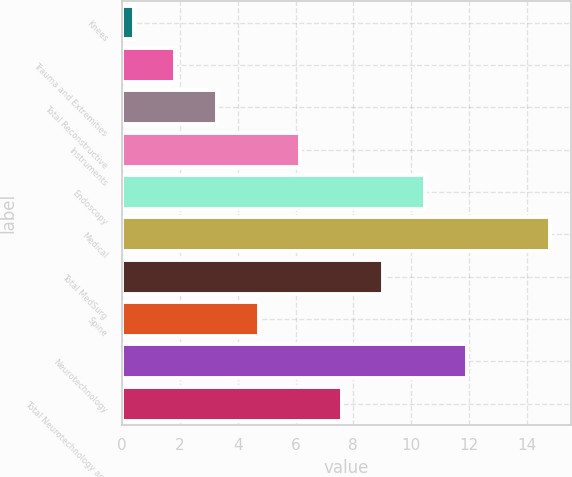Convert chart to OTSL. <chart><loc_0><loc_0><loc_500><loc_500><bar_chart><fcel>Knees<fcel>Trauma and Extremities<fcel>Total Reconstructive<fcel>Instruments<fcel>Endoscopy<fcel>Medical<fcel>Total MedSurg<fcel>Spine<fcel>Neurotechnology<fcel>Total Neurotechnology and<nl><fcel>0.4<fcel>1.84<fcel>3.28<fcel>6.16<fcel>10.48<fcel>14.8<fcel>9.04<fcel>4.72<fcel>11.92<fcel>7.6<nl></chart> 